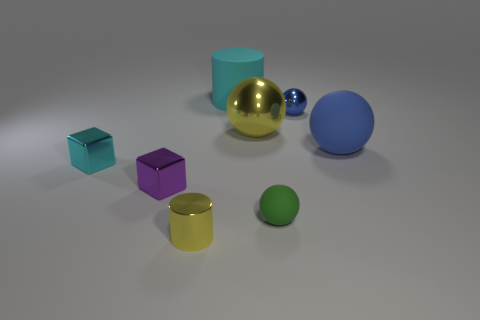What is the shape of the yellow thing that is behind the green object?
Your answer should be compact. Sphere. There is a yellow thing that is behind the matte ball that is right of the tiny sphere that is on the right side of the tiny green object; what is its size?
Provide a succinct answer. Large. Do the cyan matte object and the cyan metallic thing have the same shape?
Make the answer very short. No. How big is the thing that is behind the yellow sphere and left of the yellow shiny ball?
Make the answer very short. Large. What material is the other large thing that is the same shape as the big metal object?
Offer a terse response. Rubber. What material is the yellow thing that is behind the matte sphere that is to the right of the small blue thing?
Ensure brevity in your answer.  Metal. There is a big metallic object; is its shape the same as the matte object that is in front of the small cyan block?
Provide a short and direct response. Yes. How many matte things are tiny red cylinders or spheres?
Offer a very short reply. 2. What is the color of the rubber object to the left of the green rubber ball in front of the small metallic thing that is left of the tiny purple shiny object?
Your answer should be compact. Cyan. What number of other things are made of the same material as the big blue object?
Your answer should be compact. 2. 